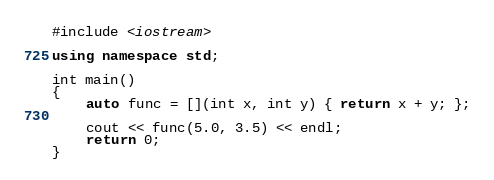Convert code to text. <code><loc_0><loc_0><loc_500><loc_500><_C++_>#include <iostream>

using namespace std;

int main()
{
	auto func = [](int x, int y) { return x + y; };

	cout << func(5.0, 3.5) << endl;
	return 0;
}
</code> 